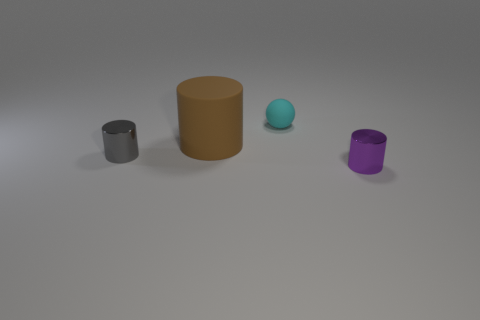Add 4 tiny cyan rubber balls. How many objects exist? 8 Subtract all cylinders. How many objects are left? 1 Add 3 purple metallic things. How many purple metallic things are left? 4 Add 4 brown cylinders. How many brown cylinders exist? 5 Subtract 0 yellow balls. How many objects are left? 4 Subtract all big brown blocks. Subtract all spheres. How many objects are left? 3 